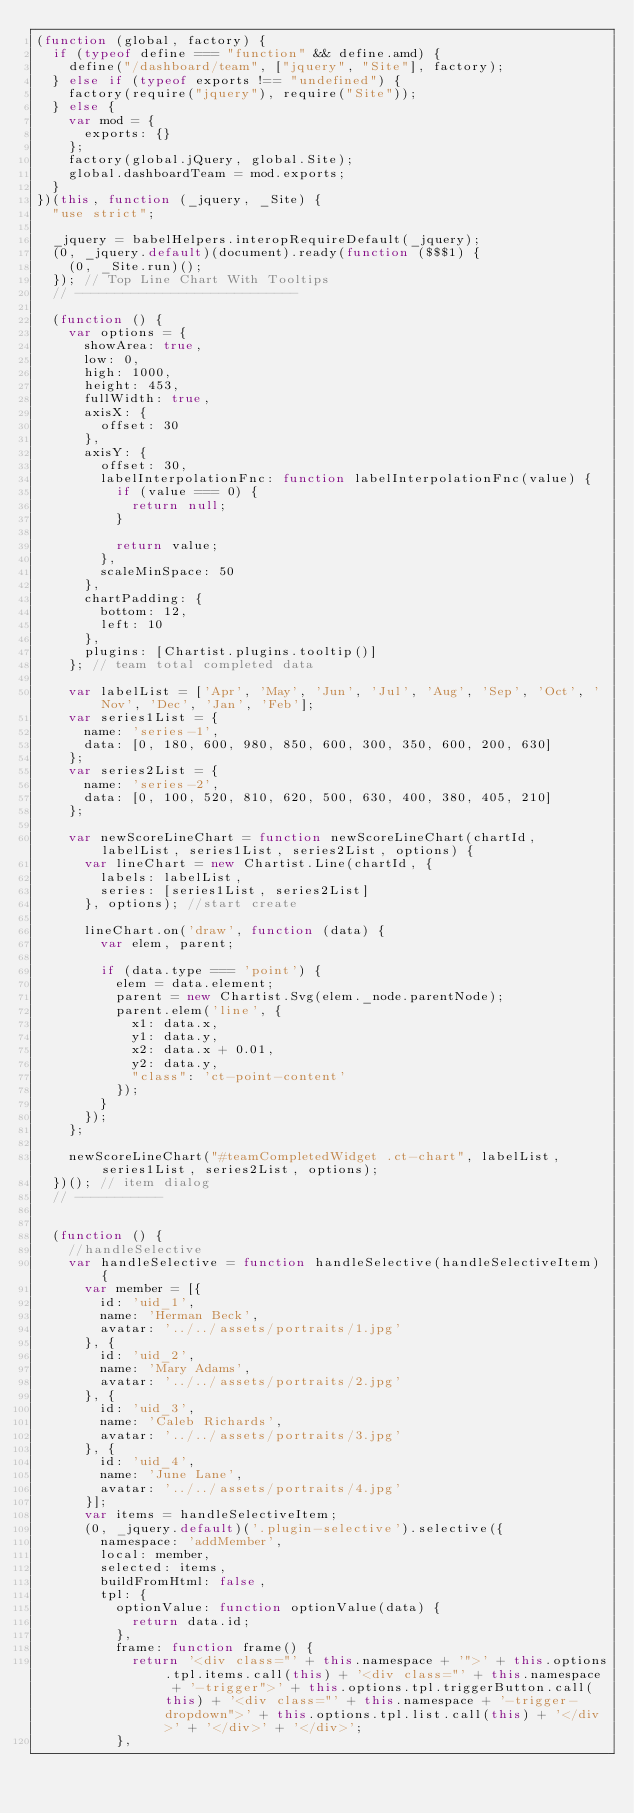<code> <loc_0><loc_0><loc_500><loc_500><_JavaScript_>(function (global, factory) {
  if (typeof define === "function" && define.amd) {
    define("/dashboard/team", ["jquery", "Site"], factory);
  } else if (typeof exports !== "undefined") {
    factory(require("jquery"), require("Site"));
  } else {
    var mod = {
      exports: {}
    };
    factory(global.jQuery, global.Site);
    global.dashboardTeam = mod.exports;
  }
})(this, function (_jquery, _Site) {
  "use strict";

  _jquery = babelHelpers.interopRequireDefault(_jquery);
  (0, _jquery.default)(document).ready(function ($$$1) {
    (0, _Site.run)();
  }); // Top Line Chart With Tooltips
  // ----------------------------

  (function () {
    var options = {
      showArea: true,
      low: 0,
      high: 1000,
      height: 453,
      fullWidth: true,
      axisX: {
        offset: 30
      },
      axisY: {
        offset: 30,
        labelInterpolationFnc: function labelInterpolationFnc(value) {
          if (value === 0) {
            return null;
          }

          return value;
        },
        scaleMinSpace: 50
      },
      chartPadding: {
        bottom: 12,
        left: 10
      },
      plugins: [Chartist.plugins.tooltip()]
    }; // team total completed data

    var labelList = ['Apr', 'May', 'Jun', 'Jul', 'Aug', 'Sep', 'Oct', 'Nov', 'Dec', 'Jan', 'Feb'];
    var series1List = {
      name: 'series-1',
      data: [0, 180, 600, 980, 850, 600, 300, 350, 600, 200, 630]
    };
    var series2List = {
      name: 'series-2',
      data: [0, 100, 520, 810, 620, 500, 630, 400, 380, 405, 210]
    };

    var newScoreLineChart = function newScoreLineChart(chartId, labelList, series1List, series2List, options) {
      var lineChart = new Chartist.Line(chartId, {
        labels: labelList,
        series: [series1List, series2List]
      }, options); //start create

      lineChart.on('draw', function (data) {
        var elem, parent;

        if (data.type === 'point') {
          elem = data.element;
          parent = new Chartist.Svg(elem._node.parentNode);
          parent.elem('line', {
            x1: data.x,
            y1: data.y,
            x2: data.x + 0.01,
            y2: data.y,
            "class": 'ct-point-content'
          });
        }
      });
    };

    newScoreLineChart("#teamCompletedWidget .ct-chart", labelList, series1List, series2List, options);
  })(); // item dialog
  // -----------


  (function () {
    //handleSelective
    var handleSelective = function handleSelective(handleSelectiveItem) {
      var member = [{
        id: 'uid_1',
        name: 'Herman Beck',
        avatar: '../../assets/portraits/1.jpg'
      }, {
        id: 'uid_2',
        name: 'Mary Adams',
        avatar: '../../assets/portraits/2.jpg'
      }, {
        id: 'uid_3',
        name: 'Caleb Richards',
        avatar: '../../assets/portraits/3.jpg'
      }, {
        id: 'uid_4',
        name: 'June Lane',
        avatar: '../../assets/portraits/4.jpg'
      }];
      var items = handleSelectiveItem;
      (0, _jquery.default)('.plugin-selective').selective({
        namespace: 'addMember',
        local: member,
        selected: items,
        buildFromHtml: false,
        tpl: {
          optionValue: function optionValue(data) {
            return data.id;
          },
          frame: function frame() {
            return '<div class="' + this.namespace + '">' + this.options.tpl.items.call(this) + '<div class="' + this.namespace + '-trigger">' + this.options.tpl.triggerButton.call(this) + '<div class="' + this.namespace + '-trigger-dropdown">' + this.options.tpl.list.call(this) + '</div>' + '</div>' + '</div>';
          },</code> 